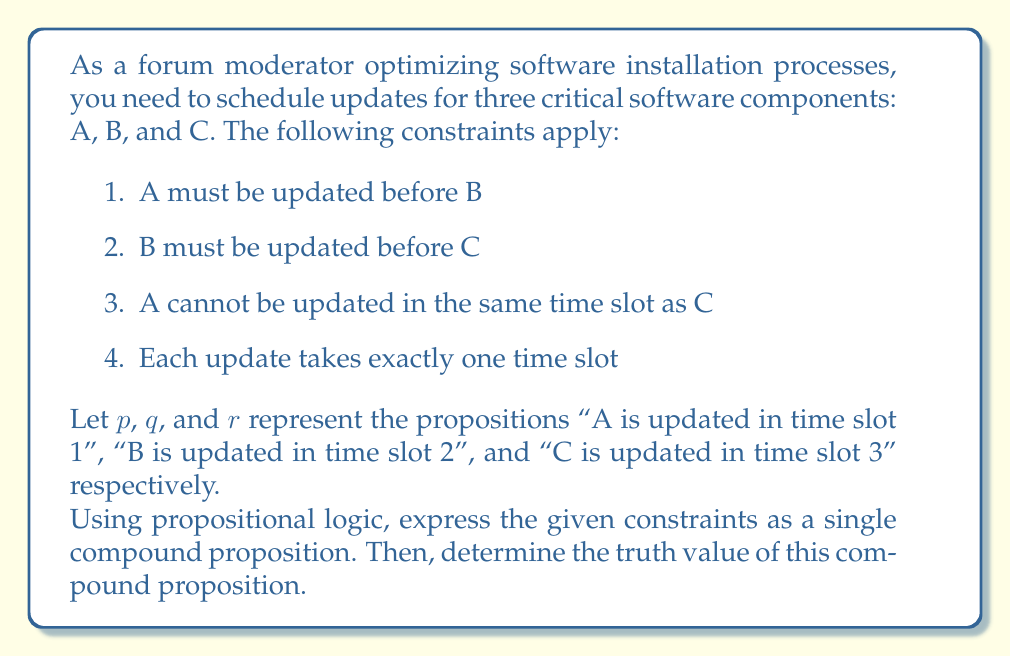Provide a solution to this math problem. Let's break this down step-by-step:

1) First, we need to express each constraint using propositional logic:

   a) A must be updated before B: $p \lor (q \land \neg p)$
   b) B must be updated before C: $q \lor (r \land \neg q)$
   c) A cannot be updated in the same time slot as C: $\neg(p \land r)$
   d) Each update takes exactly one time slot: $(p \land \neg q \land \neg r) \lor (\neg p \land q \land \neg r) \lor (\neg p \land \neg q \land r)$

2) Now, we combine these constraints using conjunction ($\land$) to create a single compound proposition:

   $$(p \lor (q \land \neg p)) \land (q \lor (r \land \neg q)) \land \neg(p \land r) \land ((p \land \neg q \land \neg r) \lor (\neg p \land q \land \neg r) \lor (\neg p \land \neg q \land r))$$

3) To determine the truth value of this compound proposition, we need to consider the possible combinations of $p$, $q$, and $r$:

   - The only valid combination that satisfies all constraints is $p = True$, $q = False$, $r = False$

4) Let's verify this:
   
   a) $p \lor (q \land \neg p)$ is True (A before B)
   b) $q \lor (r \land \neg q)$ is True (B before C, trivially satisfied)
   c) $\neg(p \land r)$ is True (A not in same slot as C)
   d) $(p \land \neg q \land \neg r)$ is True (each update in one slot)

5) Therefore, when we substitute these values into the compound proposition, it evaluates to True.
Answer: The compound proposition is True. 